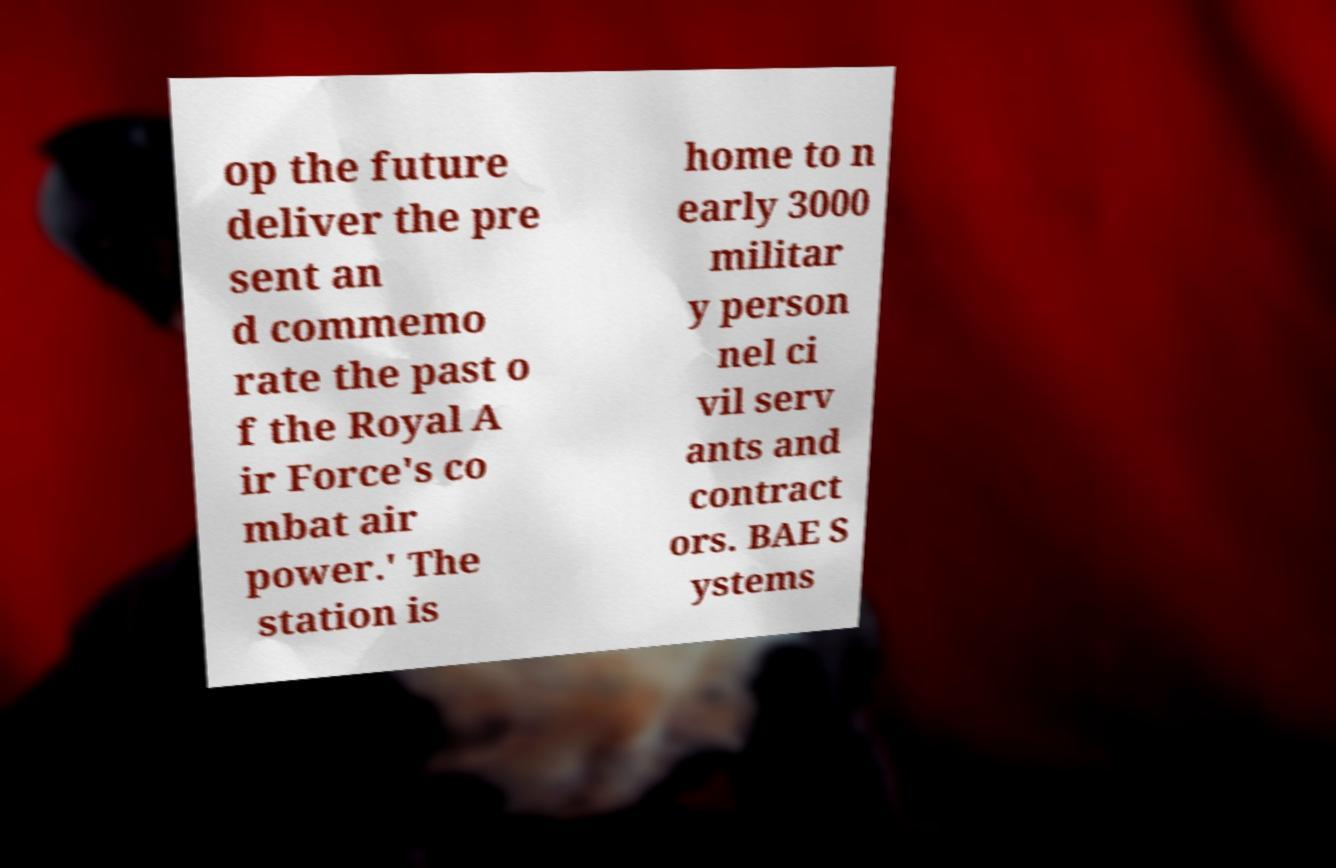There's text embedded in this image that I need extracted. Can you transcribe it verbatim? op the future deliver the pre sent an d commemo rate the past o f the Royal A ir Force's co mbat air power.' The station is home to n early 3000 militar y person nel ci vil serv ants and contract ors. BAE S ystems 